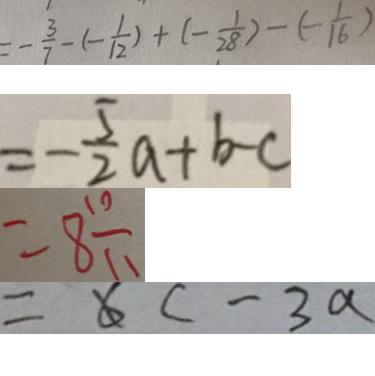Convert formula to latex. <formula><loc_0><loc_0><loc_500><loc_500>= - \frac { 3 } { 7 } - ( - \frac { 1 } { 1 2 } ) + ( - \frac { 1 } { 2 8 } ) - ( - 1 6 ) 
 = - \frac { 5 } { 2 } a + b - c 
 = 8 \frac { 1 0 } { 1 1 } 
 = 6 c - 3 a</formula> 